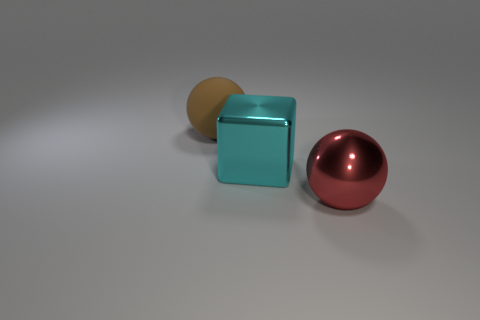Could you describe the lighting in the scene? The lighting in the scene seems to be soft and diffused, coming from above, as indicated by the gentle shadows cast by the objects on the ground and the subtle highlights on the objects' surfaces. 